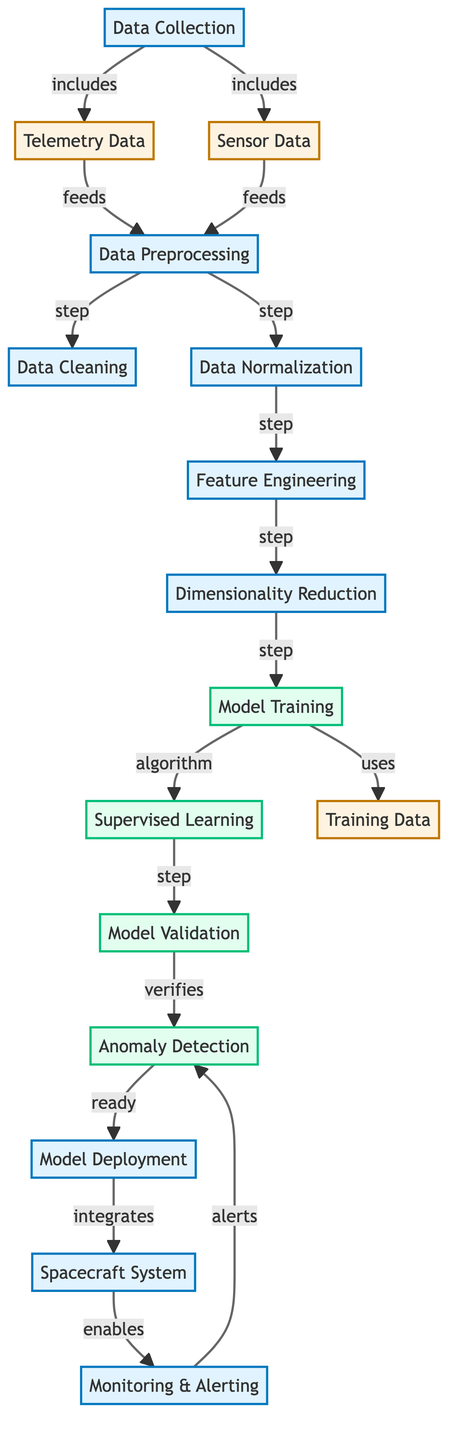What are the two types of data collected? The diagram shows "Telemetry Data" and "Sensor Data" as parts of the "Data Collection" process node. Both types are explicitly mentioned as included in the data collection stage.
Answer: Telemetry Data, Sensor Data How many preprocessing steps are shown? The diagram lists three preprocessing steps: "Data Cleaning," "Data Normalization," and "Feature Engineering." These steps are connected sequentially after the preprocessing node, clearly outlining a total of three specific steps.
Answer: Three What follows "Dimensionality Reduction" in the flow? After "Dimensionality Reduction," the next step is "Model Training," which illustrates the sequential flow of processes in the diagram heading toward model development.
Answer: Model Training Which process enables monitoring and alerting? The "Spacecraft System" node connects with the "Monitoring & Alerting" process, indicating that the spacecraft system is responsible for enabling monitoring and alerting for anomalies detected.
Answer: Spacecraft System Which step verifies the "Anomaly Detection"? The diagram indicates that the "Validation" process verifies the "Anomaly Detection," thus confirming that validation checks the model's capacity to detect anomalies accurately before deployment.
Answer: Validation What type of learning is utilized during the model training? The diagram clearly specifies "Supervised Learning" as the type of learning used within the "Model Training" process, demonstrably focusing on applying supervised techniques to train the model.
Answer: Supervised Learning What is the final step before deployment in the diagram? The step leading directly to "Deployment" is "Anomaly Detection" which indicates that prior to deploying the model, it must successfully perform anomaly detection.
Answer: Anomaly Detection What process does "Anomaly Detection" alert on? The "Monitoring & Alerting" process receives alerts from "Anomaly Detection," highlighting the operational feedback loop ensuring timely reactions to detected anomalies.
Answer: Anomaly Detection 